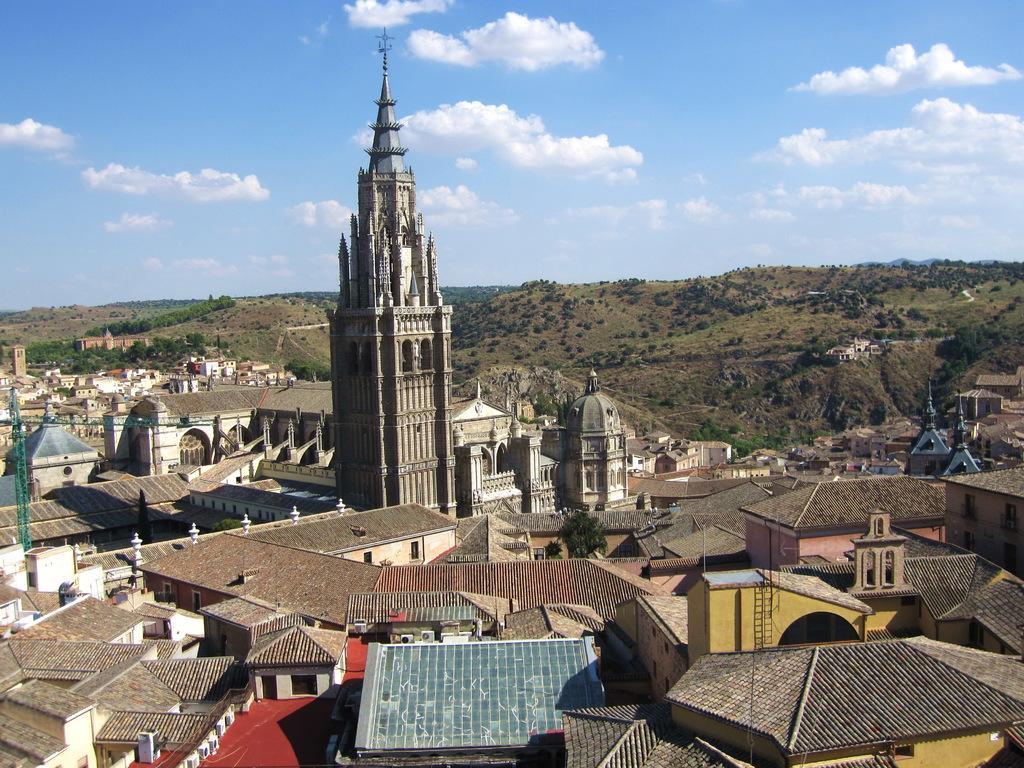Please provide a concise description of this image. In this image I can see few buildings, windows, trees and the sky is in blue and white color. 